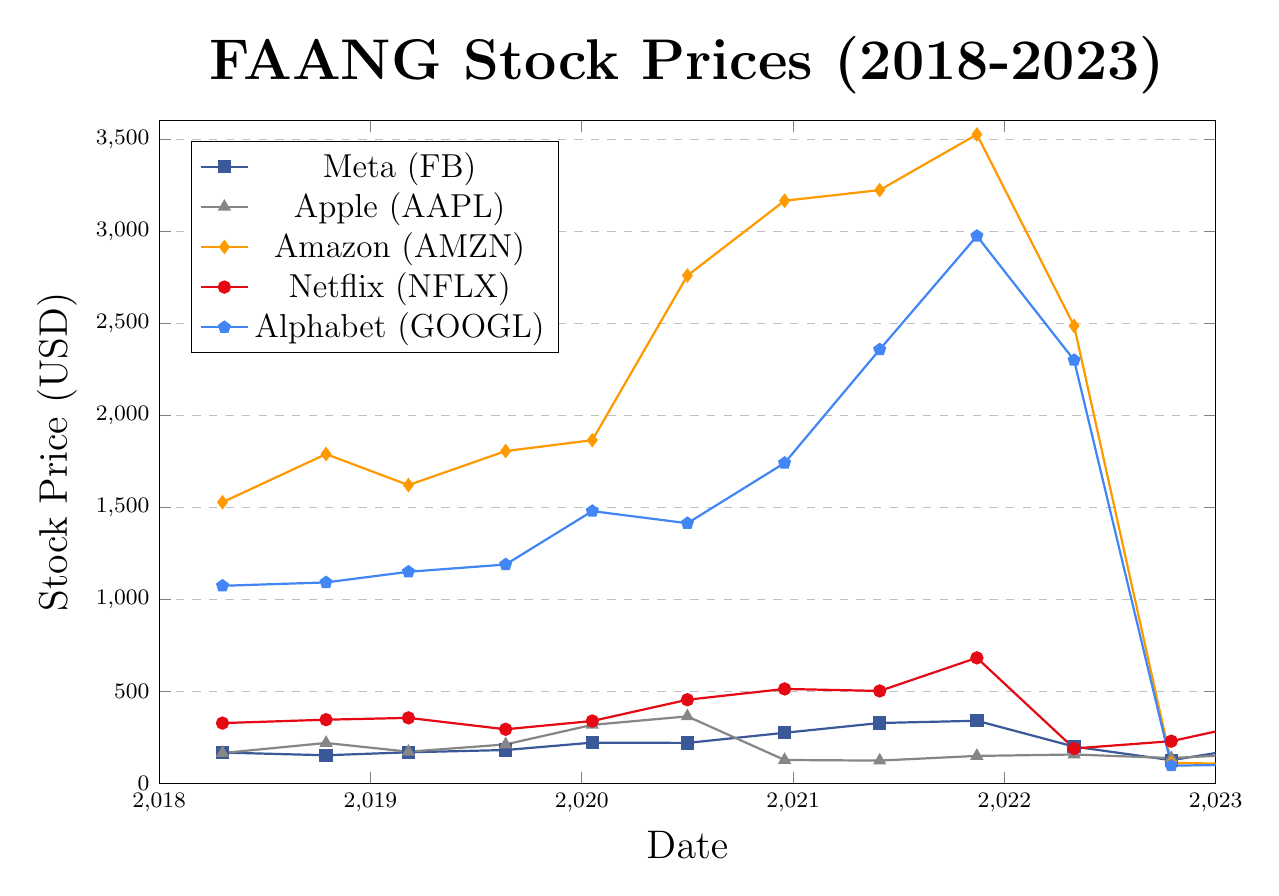What was the highest stock price for Apple during the given period? The highest stock price for Apple can be identified by looking for the tallest point on the Apple (AAPL) line. The tallest point corresponds to a value on the y-axis. In this case, it's around the time 2020-06-30 at roughly $364.80.
Answer: 364.80 Which company had the lowest stock price in October 2022? To determine the company with the lowest stock price in October 2022, look at the stock prices for all companies during that month and identify the minimum value. Here, Amazon (AMZN) had the lowest stock price around 112.53.
Answer: Amazon (AMZN) Compare the stock prices of Netflix and Meta at the end of March 2023. Which one is higher? First, find the stock prices for both Netflix and Meta at the end of March 2023. Netflix's price is around 345.48 and Meta's price is around 211.94. A quick numerical comparison shows that Netflix's price is higher.
Answer: Netflix What is the difference in Amazon's stock prices between its highest point and its lowest point? Amazon's highest stock price is around 3525.15 at the end of 2021, and its lowest stock price is around 103.29 in March 2023. Subtracting 103.29 from 3525.15 gives the difference: 3525.15 - 103.29.
Answer: 3421.86 Which company showed the largest gain in stock price from January 2020 to May 2021? Check each company's stock price in January 2020 and May 2021, then calculate the difference for each. Meta increased from 222.14 to 328.73, Apple from 318.73 to 124.61, Amazon from 1864.72 to 3223.07, Netflix from 339.67 to 502.81, and Google from 1479.52 to 2356.85. The largest increase is for Amazon, going from 1864.72 to 3223.07.
Answer: Amazon (AMZN) How did Alphabet's stock price change from November 2021 to April 2022? Alphabet's stock price in November 2021 was around 2973.56 and in April 2022 it was around 2299.33. The change is calculated by subtracting the April value from the November value: 2973.56 - 2299.33.
Answer: -674.23 In terms of stock price, which company had the most considerable fluctuation (difference between highest and lowest prices) between 2018 and 2023? To find the company with the largest fluctuation, calculate the difference between the highest and lowest stock prices for each company over the period. Compute: Meta (340.89 - 126.76), Apple (364.80 - 124.61), Amazon (3525.15 - 103.29), Netflix (682.61 - 190.36), and Google (2973.56 - 97.18). Amazon shows the largest fluctuation.
Answer: Amazon (AMZN) What was the trend of Meta's stock price from 2019 to 2023? Observe the specific trend line of Meta from 2019 to 2023. Meta's stock price increased gradually and peaked around the end of 2021 (340.89) before a significant drop in 2022 and a partial recovery in 2023 (211.94).
Answer: Peaked and then dropped with partial recovery Which two companies had almost similar stock prices in early 2021? Look at the stock prices of all companies near early 2021. We can observe that around the end of May 2021, Apple and Netflix had stock prices close to each other at 124.61 and 502.81, respectively, showing minimal resemblance compared to overall values.
Answer: Apple and Netflix 